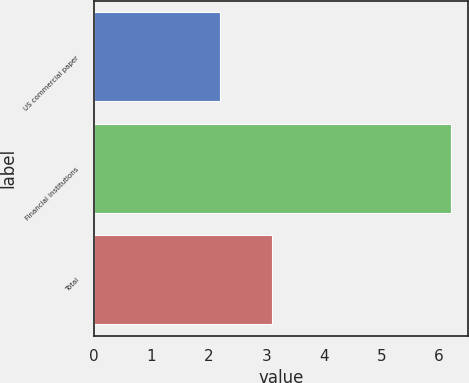<chart> <loc_0><loc_0><loc_500><loc_500><bar_chart><fcel>US commercial paper<fcel>Financial institutions<fcel>Total<nl><fcel>2.2<fcel>6.2<fcel>3.1<nl></chart> 